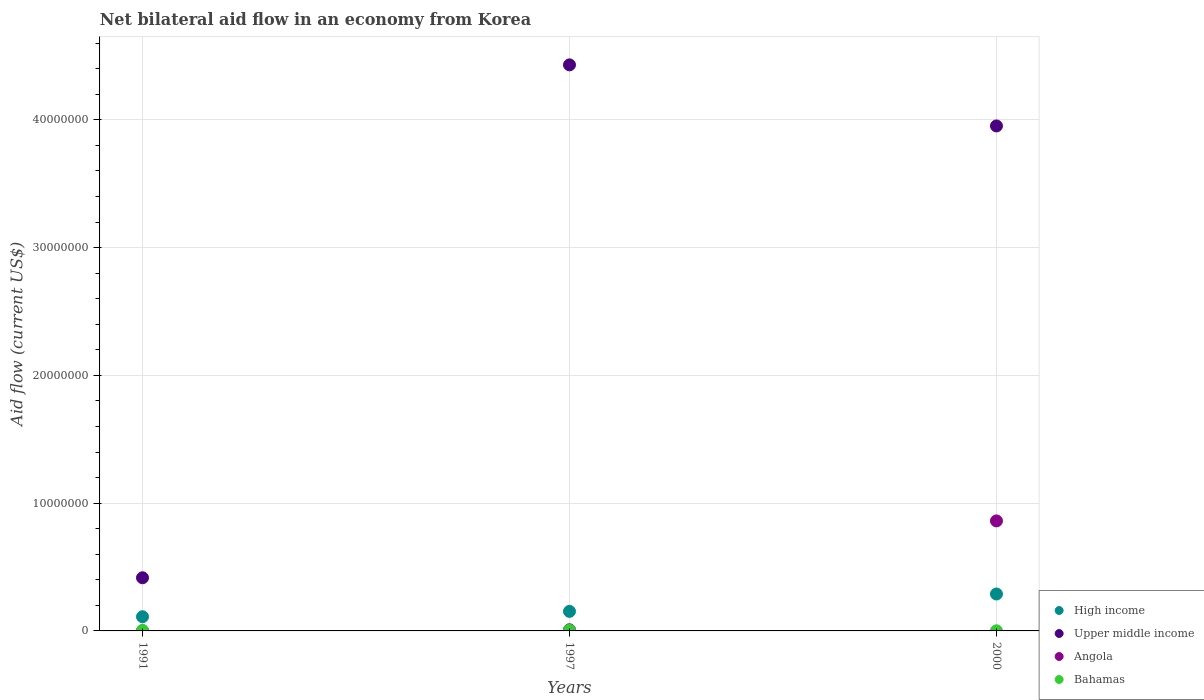How many different coloured dotlines are there?
Provide a succinct answer. 4. Is the number of dotlines equal to the number of legend labels?
Your response must be concise. Yes. What is the net bilateral aid flow in Upper middle income in 1997?
Your answer should be very brief. 4.43e+07. Across all years, what is the maximum net bilateral aid flow in High income?
Ensure brevity in your answer.  2.89e+06. What is the difference between the net bilateral aid flow in Bahamas in 1991 and the net bilateral aid flow in Upper middle income in 1997?
Keep it short and to the point. -4.43e+07. What is the average net bilateral aid flow in Upper middle income per year?
Keep it short and to the point. 2.93e+07. In the year 1997, what is the difference between the net bilateral aid flow in Angola and net bilateral aid flow in Upper middle income?
Keep it short and to the point. -4.42e+07. In how many years, is the net bilateral aid flow in Upper middle income greater than 20000000 US$?
Keep it short and to the point. 2. What is the ratio of the net bilateral aid flow in Angola in 1997 to that in 2000?
Offer a very short reply. 0.01. What is the difference between the highest and the second highest net bilateral aid flow in Upper middle income?
Ensure brevity in your answer.  4.78e+06. What is the difference between the highest and the lowest net bilateral aid flow in Upper middle income?
Your response must be concise. 4.01e+07. In how many years, is the net bilateral aid flow in High income greater than the average net bilateral aid flow in High income taken over all years?
Your response must be concise. 1. Is it the case that in every year, the sum of the net bilateral aid flow in Upper middle income and net bilateral aid flow in Bahamas  is greater than the net bilateral aid flow in High income?
Your answer should be compact. Yes. Is the net bilateral aid flow in Angola strictly greater than the net bilateral aid flow in High income over the years?
Provide a short and direct response. No. Is the net bilateral aid flow in Angola strictly less than the net bilateral aid flow in Upper middle income over the years?
Keep it short and to the point. Yes. How many dotlines are there?
Your response must be concise. 4. What is the title of the graph?
Offer a very short reply. Net bilateral aid flow in an economy from Korea. What is the label or title of the X-axis?
Ensure brevity in your answer.  Years. What is the label or title of the Y-axis?
Make the answer very short. Aid flow (current US$). What is the Aid flow (current US$) in High income in 1991?
Offer a terse response. 1.11e+06. What is the Aid flow (current US$) in Upper middle income in 1991?
Provide a succinct answer. 4.16e+06. What is the Aid flow (current US$) in High income in 1997?
Offer a very short reply. 1.53e+06. What is the Aid flow (current US$) of Upper middle income in 1997?
Offer a very short reply. 4.43e+07. What is the Aid flow (current US$) of Angola in 1997?
Provide a succinct answer. 9.00e+04. What is the Aid flow (current US$) in Bahamas in 1997?
Ensure brevity in your answer.  6.00e+04. What is the Aid flow (current US$) in High income in 2000?
Provide a short and direct response. 2.89e+06. What is the Aid flow (current US$) of Upper middle income in 2000?
Provide a short and direct response. 3.95e+07. What is the Aid flow (current US$) of Angola in 2000?
Your response must be concise. 8.61e+06. What is the Aid flow (current US$) in Bahamas in 2000?
Make the answer very short. 10000. Across all years, what is the maximum Aid flow (current US$) of High income?
Offer a terse response. 2.89e+06. Across all years, what is the maximum Aid flow (current US$) of Upper middle income?
Keep it short and to the point. 4.43e+07. Across all years, what is the maximum Aid flow (current US$) in Angola?
Your response must be concise. 8.61e+06. Across all years, what is the maximum Aid flow (current US$) in Bahamas?
Offer a very short reply. 6.00e+04. Across all years, what is the minimum Aid flow (current US$) of High income?
Provide a succinct answer. 1.11e+06. Across all years, what is the minimum Aid flow (current US$) in Upper middle income?
Offer a very short reply. 4.16e+06. Across all years, what is the minimum Aid flow (current US$) in Bahamas?
Your response must be concise. 10000. What is the total Aid flow (current US$) of High income in the graph?
Offer a very short reply. 5.53e+06. What is the total Aid flow (current US$) in Upper middle income in the graph?
Ensure brevity in your answer.  8.80e+07. What is the total Aid flow (current US$) in Angola in the graph?
Your response must be concise. 8.71e+06. What is the difference between the Aid flow (current US$) in High income in 1991 and that in 1997?
Give a very brief answer. -4.20e+05. What is the difference between the Aid flow (current US$) in Upper middle income in 1991 and that in 1997?
Ensure brevity in your answer.  -4.01e+07. What is the difference between the Aid flow (current US$) in High income in 1991 and that in 2000?
Give a very brief answer. -1.78e+06. What is the difference between the Aid flow (current US$) in Upper middle income in 1991 and that in 2000?
Provide a short and direct response. -3.54e+07. What is the difference between the Aid flow (current US$) in Angola in 1991 and that in 2000?
Give a very brief answer. -8.60e+06. What is the difference between the Aid flow (current US$) of High income in 1997 and that in 2000?
Give a very brief answer. -1.36e+06. What is the difference between the Aid flow (current US$) of Upper middle income in 1997 and that in 2000?
Your answer should be very brief. 4.78e+06. What is the difference between the Aid flow (current US$) of Angola in 1997 and that in 2000?
Keep it short and to the point. -8.52e+06. What is the difference between the Aid flow (current US$) in Bahamas in 1997 and that in 2000?
Provide a succinct answer. 5.00e+04. What is the difference between the Aid flow (current US$) of High income in 1991 and the Aid flow (current US$) of Upper middle income in 1997?
Keep it short and to the point. -4.32e+07. What is the difference between the Aid flow (current US$) in High income in 1991 and the Aid flow (current US$) in Angola in 1997?
Offer a very short reply. 1.02e+06. What is the difference between the Aid flow (current US$) of High income in 1991 and the Aid flow (current US$) of Bahamas in 1997?
Your answer should be compact. 1.05e+06. What is the difference between the Aid flow (current US$) of Upper middle income in 1991 and the Aid flow (current US$) of Angola in 1997?
Offer a very short reply. 4.07e+06. What is the difference between the Aid flow (current US$) of Upper middle income in 1991 and the Aid flow (current US$) of Bahamas in 1997?
Your answer should be compact. 4.10e+06. What is the difference between the Aid flow (current US$) of Angola in 1991 and the Aid flow (current US$) of Bahamas in 1997?
Make the answer very short. -5.00e+04. What is the difference between the Aid flow (current US$) in High income in 1991 and the Aid flow (current US$) in Upper middle income in 2000?
Your response must be concise. -3.84e+07. What is the difference between the Aid flow (current US$) of High income in 1991 and the Aid flow (current US$) of Angola in 2000?
Your answer should be compact. -7.50e+06. What is the difference between the Aid flow (current US$) in High income in 1991 and the Aid flow (current US$) in Bahamas in 2000?
Ensure brevity in your answer.  1.10e+06. What is the difference between the Aid flow (current US$) of Upper middle income in 1991 and the Aid flow (current US$) of Angola in 2000?
Provide a short and direct response. -4.45e+06. What is the difference between the Aid flow (current US$) in Upper middle income in 1991 and the Aid flow (current US$) in Bahamas in 2000?
Your response must be concise. 4.15e+06. What is the difference between the Aid flow (current US$) in Angola in 1991 and the Aid flow (current US$) in Bahamas in 2000?
Your response must be concise. 0. What is the difference between the Aid flow (current US$) in High income in 1997 and the Aid flow (current US$) in Upper middle income in 2000?
Provide a short and direct response. -3.80e+07. What is the difference between the Aid flow (current US$) in High income in 1997 and the Aid flow (current US$) in Angola in 2000?
Your response must be concise. -7.08e+06. What is the difference between the Aid flow (current US$) of High income in 1997 and the Aid flow (current US$) of Bahamas in 2000?
Offer a very short reply. 1.52e+06. What is the difference between the Aid flow (current US$) of Upper middle income in 1997 and the Aid flow (current US$) of Angola in 2000?
Provide a succinct answer. 3.57e+07. What is the difference between the Aid flow (current US$) in Upper middle income in 1997 and the Aid flow (current US$) in Bahamas in 2000?
Your answer should be very brief. 4.43e+07. What is the average Aid flow (current US$) in High income per year?
Ensure brevity in your answer.  1.84e+06. What is the average Aid flow (current US$) of Upper middle income per year?
Provide a short and direct response. 2.93e+07. What is the average Aid flow (current US$) in Angola per year?
Offer a very short reply. 2.90e+06. What is the average Aid flow (current US$) of Bahamas per year?
Provide a short and direct response. 3.67e+04. In the year 1991, what is the difference between the Aid flow (current US$) of High income and Aid flow (current US$) of Upper middle income?
Make the answer very short. -3.05e+06. In the year 1991, what is the difference between the Aid flow (current US$) of High income and Aid flow (current US$) of Angola?
Keep it short and to the point. 1.10e+06. In the year 1991, what is the difference between the Aid flow (current US$) of High income and Aid flow (current US$) of Bahamas?
Provide a succinct answer. 1.07e+06. In the year 1991, what is the difference between the Aid flow (current US$) of Upper middle income and Aid flow (current US$) of Angola?
Your answer should be very brief. 4.15e+06. In the year 1991, what is the difference between the Aid flow (current US$) of Upper middle income and Aid flow (current US$) of Bahamas?
Offer a terse response. 4.12e+06. In the year 1991, what is the difference between the Aid flow (current US$) of Angola and Aid flow (current US$) of Bahamas?
Offer a terse response. -3.00e+04. In the year 1997, what is the difference between the Aid flow (current US$) of High income and Aid flow (current US$) of Upper middle income?
Make the answer very short. -4.28e+07. In the year 1997, what is the difference between the Aid flow (current US$) of High income and Aid flow (current US$) of Angola?
Provide a short and direct response. 1.44e+06. In the year 1997, what is the difference between the Aid flow (current US$) of High income and Aid flow (current US$) of Bahamas?
Your answer should be very brief. 1.47e+06. In the year 1997, what is the difference between the Aid flow (current US$) of Upper middle income and Aid flow (current US$) of Angola?
Ensure brevity in your answer.  4.42e+07. In the year 1997, what is the difference between the Aid flow (current US$) of Upper middle income and Aid flow (current US$) of Bahamas?
Your answer should be very brief. 4.42e+07. In the year 2000, what is the difference between the Aid flow (current US$) of High income and Aid flow (current US$) of Upper middle income?
Ensure brevity in your answer.  -3.66e+07. In the year 2000, what is the difference between the Aid flow (current US$) of High income and Aid flow (current US$) of Angola?
Offer a terse response. -5.72e+06. In the year 2000, what is the difference between the Aid flow (current US$) of High income and Aid flow (current US$) of Bahamas?
Your answer should be very brief. 2.88e+06. In the year 2000, what is the difference between the Aid flow (current US$) in Upper middle income and Aid flow (current US$) in Angola?
Keep it short and to the point. 3.09e+07. In the year 2000, what is the difference between the Aid flow (current US$) of Upper middle income and Aid flow (current US$) of Bahamas?
Offer a very short reply. 3.95e+07. In the year 2000, what is the difference between the Aid flow (current US$) of Angola and Aid flow (current US$) of Bahamas?
Your answer should be very brief. 8.60e+06. What is the ratio of the Aid flow (current US$) in High income in 1991 to that in 1997?
Provide a short and direct response. 0.73. What is the ratio of the Aid flow (current US$) in Upper middle income in 1991 to that in 1997?
Provide a short and direct response. 0.09. What is the ratio of the Aid flow (current US$) of High income in 1991 to that in 2000?
Offer a very short reply. 0.38. What is the ratio of the Aid flow (current US$) in Upper middle income in 1991 to that in 2000?
Your response must be concise. 0.11. What is the ratio of the Aid flow (current US$) of Angola in 1991 to that in 2000?
Keep it short and to the point. 0. What is the ratio of the Aid flow (current US$) in Bahamas in 1991 to that in 2000?
Your answer should be compact. 4. What is the ratio of the Aid flow (current US$) of High income in 1997 to that in 2000?
Offer a very short reply. 0.53. What is the ratio of the Aid flow (current US$) of Upper middle income in 1997 to that in 2000?
Offer a terse response. 1.12. What is the ratio of the Aid flow (current US$) of Angola in 1997 to that in 2000?
Your response must be concise. 0.01. What is the difference between the highest and the second highest Aid flow (current US$) of High income?
Your answer should be compact. 1.36e+06. What is the difference between the highest and the second highest Aid flow (current US$) in Upper middle income?
Provide a succinct answer. 4.78e+06. What is the difference between the highest and the second highest Aid flow (current US$) of Angola?
Ensure brevity in your answer.  8.52e+06. What is the difference between the highest and the second highest Aid flow (current US$) in Bahamas?
Give a very brief answer. 2.00e+04. What is the difference between the highest and the lowest Aid flow (current US$) in High income?
Offer a terse response. 1.78e+06. What is the difference between the highest and the lowest Aid flow (current US$) of Upper middle income?
Provide a short and direct response. 4.01e+07. What is the difference between the highest and the lowest Aid flow (current US$) in Angola?
Your answer should be very brief. 8.60e+06. 